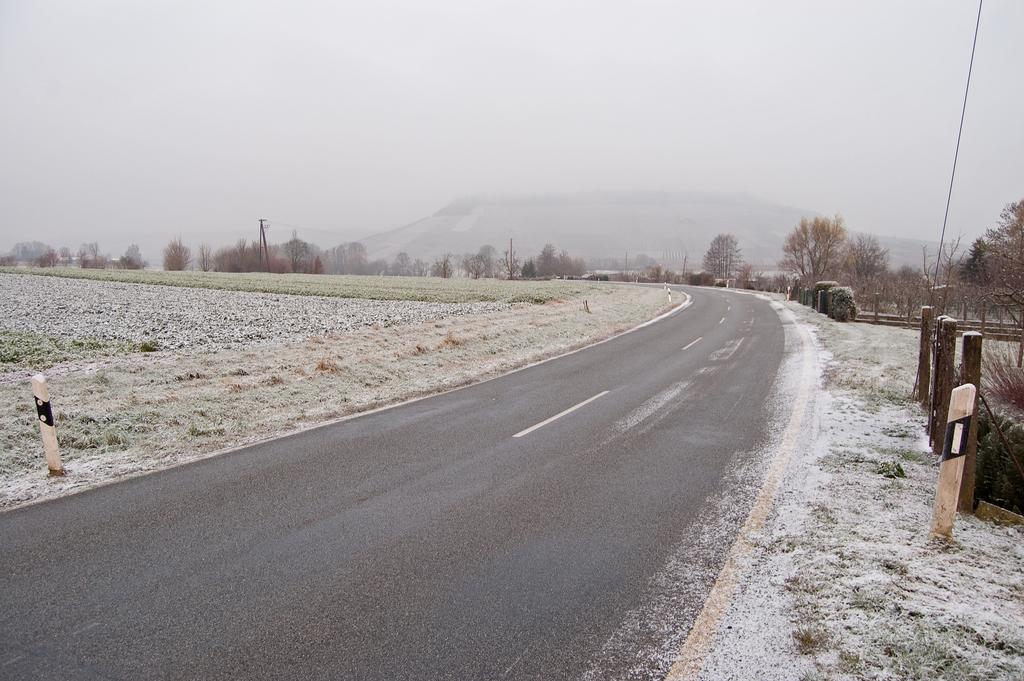What is located at the bottom of the image? There is a road at the bottom of the image. What type of vegetation is on the right side of the image? There are trees on the right side of the image. What can be seen in the background of the image? There are hills in the background of the image. What is visible at the top of the image? The sky is visible at the top of the image. What type of fear can be seen on the face of the hen in the image? There is no hen present in the image, so it is not possible to determine if there is any fear or emotion on its face. 